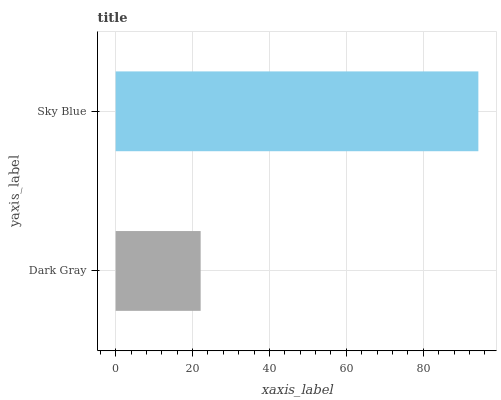Is Dark Gray the minimum?
Answer yes or no. Yes. Is Sky Blue the maximum?
Answer yes or no. Yes. Is Sky Blue the minimum?
Answer yes or no. No. Is Sky Blue greater than Dark Gray?
Answer yes or no. Yes. Is Dark Gray less than Sky Blue?
Answer yes or no. Yes. Is Dark Gray greater than Sky Blue?
Answer yes or no. No. Is Sky Blue less than Dark Gray?
Answer yes or no. No. Is Sky Blue the high median?
Answer yes or no. Yes. Is Dark Gray the low median?
Answer yes or no. Yes. Is Dark Gray the high median?
Answer yes or no. No. Is Sky Blue the low median?
Answer yes or no. No. 